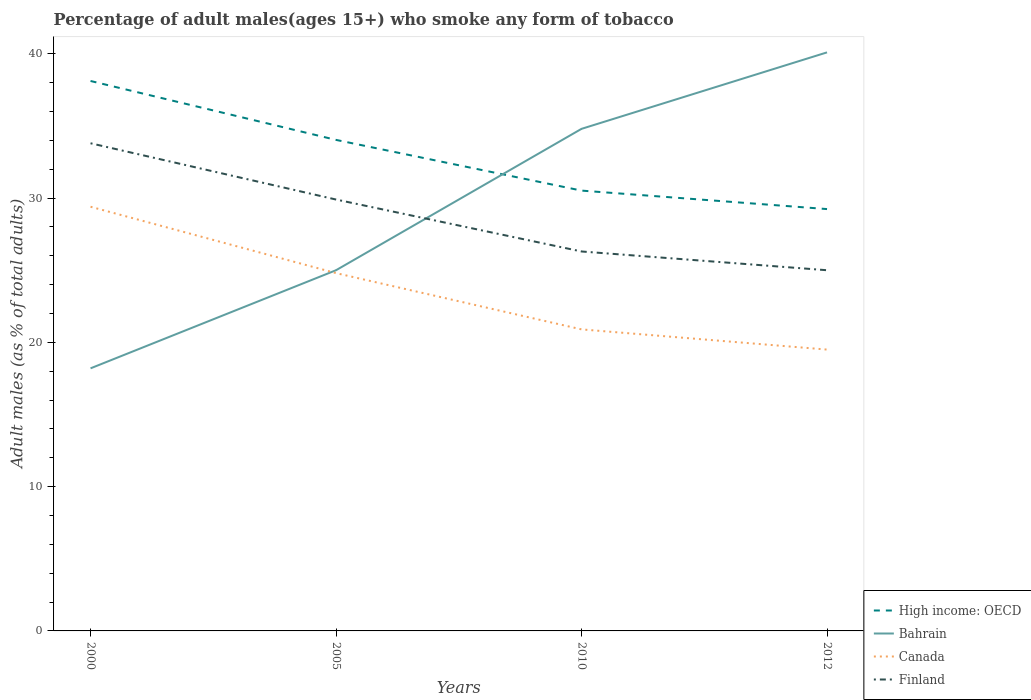How many different coloured lines are there?
Keep it short and to the point. 4. Is the number of lines equal to the number of legend labels?
Offer a terse response. Yes. What is the total percentage of adult males who smoke in Bahrain in the graph?
Your answer should be very brief. -9.8. What is the difference between the highest and the second highest percentage of adult males who smoke in Bahrain?
Make the answer very short. 21.9. How many lines are there?
Ensure brevity in your answer.  4. What is the difference between two consecutive major ticks on the Y-axis?
Offer a very short reply. 10. Does the graph contain any zero values?
Keep it short and to the point. No. Does the graph contain grids?
Offer a terse response. No. How are the legend labels stacked?
Give a very brief answer. Vertical. What is the title of the graph?
Your response must be concise. Percentage of adult males(ages 15+) who smoke any form of tobacco. What is the label or title of the X-axis?
Ensure brevity in your answer.  Years. What is the label or title of the Y-axis?
Offer a very short reply. Adult males (as % of total adults). What is the Adult males (as % of total adults) of High income: OECD in 2000?
Make the answer very short. 38.12. What is the Adult males (as % of total adults) in Bahrain in 2000?
Your answer should be compact. 18.2. What is the Adult males (as % of total adults) in Canada in 2000?
Keep it short and to the point. 29.4. What is the Adult males (as % of total adults) of Finland in 2000?
Offer a terse response. 33.8. What is the Adult males (as % of total adults) of High income: OECD in 2005?
Provide a succinct answer. 34.03. What is the Adult males (as % of total adults) of Bahrain in 2005?
Your answer should be very brief. 25. What is the Adult males (as % of total adults) of Canada in 2005?
Ensure brevity in your answer.  24.8. What is the Adult males (as % of total adults) of Finland in 2005?
Your response must be concise. 29.9. What is the Adult males (as % of total adults) in High income: OECD in 2010?
Give a very brief answer. 30.52. What is the Adult males (as % of total adults) of Bahrain in 2010?
Provide a succinct answer. 34.8. What is the Adult males (as % of total adults) of Canada in 2010?
Offer a very short reply. 20.9. What is the Adult males (as % of total adults) of Finland in 2010?
Ensure brevity in your answer.  26.3. What is the Adult males (as % of total adults) of High income: OECD in 2012?
Your response must be concise. 29.24. What is the Adult males (as % of total adults) in Bahrain in 2012?
Your answer should be very brief. 40.1. What is the Adult males (as % of total adults) in Canada in 2012?
Your answer should be compact. 19.5. What is the Adult males (as % of total adults) in Finland in 2012?
Your answer should be compact. 25. Across all years, what is the maximum Adult males (as % of total adults) of High income: OECD?
Offer a very short reply. 38.12. Across all years, what is the maximum Adult males (as % of total adults) in Bahrain?
Your answer should be very brief. 40.1. Across all years, what is the maximum Adult males (as % of total adults) in Canada?
Provide a short and direct response. 29.4. Across all years, what is the maximum Adult males (as % of total adults) of Finland?
Provide a short and direct response. 33.8. Across all years, what is the minimum Adult males (as % of total adults) of High income: OECD?
Your answer should be very brief. 29.24. Across all years, what is the minimum Adult males (as % of total adults) in Bahrain?
Your answer should be very brief. 18.2. Across all years, what is the minimum Adult males (as % of total adults) of Canada?
Give a very brief answer. 19.5. What is the total Adult males (as % of total adults) in High income: OECD in the graph?
Ensure brevity in your answer.  131.91. What is the total Adult males (as % of total adults) of Bahrain in the graph?
Provide a succinct answer. 118.1. What is the total Adult males (as % of total adults) of Canada in the graph?
Give a very brief answer. 94.6. What is the total Adult males (as % of total adults) in Finland in the graph?
Your answer should be compact. 115. What is the difference between the Adult males (as % of total adults) in High income: OECD in 2000 and that in 2005?
Give a very brief answer. 4.08. What is the difference between the Adult males (as % of total adults) of Bahrain in 2000 and that in 2005?
Make the answer very short. -6.8. What is the difference between the Adult males (as % of total adults) of High income: OECD in 2000 and that in 2010?
Offer a very short reply. 7.6. What is the difference between the Adult males (as % of total adults) in Bahrain in 2000 and that in 2010?
Offer a very short reply. -16.6. What is the difference between the Adult males (as % of total adults) in High income: OECD in 2000 and that in 2012?
Ensure brevity in your answer.  8.88. What is the difference between the Adult males (as % of total adults) in Bahrain in 2000 and that in 2012?
Give a very brief answer. -21.9. What is the difference between the Adult males (as % of total adults) of High income: OECD in 2005 and that in 2010?
Offer a very short reply. 3.51. What is the difference between the Adult males (as % of total adults) of Bahrain in 2005 and that in 2010?
Provide a short and direct response. -9.8. What is the difference between the Adult males (as % of total adults) of Canada in 2005 and that in 2010?
Your answer should be very brief. 3.9. What is the difference between the Adult males (as % of total adults) in High income: OECD in 2005 and that in 2012?
Ensure brevity in your answer.  4.79. What is the difference between the Adult males (as % of total adults) in Bahrain in 2005 and that in 2012?
Offer a very short reply. -15.1. What is the difference between the Adult males (as % of total adults) of High income: OECD in 2010 and that in 2012?
Ensure brevity in your answer.  1.28. What is the difference between the Adult males (as % of total adults) in Finland in 2010 and that in 2012?
Keep it short and to the point. 1.3. What is the difference between the Adult males (as % of total adults) of High income: OECD in 2000 and the Adult males (as % of total adults) of Bahrain in 2005?
Make the answer very short. 13.12. What is the difference between the Adult males (as % of total adults) of High income: OECD in 2000 and the Adult males (as % of total adults) of Canada in 2005?
Ensure brevity in your answer.  13.32. What is the difference between the Adult males (as % of total adults) in High income: OECD in 2000 and the Adult males (as % of total adults) in Finland in 2005?
Offer a very short reply. 8.22. What is the difference between the Adult males (as % of total adults) of Bahrain in 2000 and the Adult males (as % of total adults) of Canada in 2005?
Offer a terse response. -6.6. What is the difference between the Adult males (as % of total adults) in Bahrain in 2000 and the Adult males (as % of total adults) in Finland in 2005?
Make the answer very short. -11.7. What is the difference between the Adult males (as % of total adults) in Canada in 2000 and the Adult males (as % of total adults) in Finland in 2005?
Keep it short and to the point. -0.5. What is the difference between the Adult males (as % of total adults) in High income: OECD in 2000 and the Adult males (as % of total adults) in Bahrain in 2010?
Provide a short and direct response. 3.32. What is the difference between the Adult males (as % of total adults) in High income: OECD in 2000 and the Adult males (as % of total adults) in Canada in 2010?
Give a very brief answer. 17.22. What is the difference between the Adult males (as % of total adults) of High income: OECD in 2000 and the Adult males (as % of total adults) of Finland in 2010?
Offer a terse response. 11.82. What is the difference between the Adult males (as % of total adults) of Bahrain in 2000 and the Adult males (as % of total adults) of Canada in 2010?
Your response must be concise. -2.7. What is the difference between the Adult males (as % of total adults) in Bahrain in 2000 and the Adult males (as % of total adults) in Finland in 2010?
Keep it short and to the point. -8.1. What is the difference between the Adult males (as % of total adults) in Canada in 2000 and the Adult males (as % of total adults) in Finland in 2010?
Your answer should be compact. 3.1. What is the difference between the Adult males (as % of total adults) of High income: OECD in 2000 and the Adult males (as % of total adults) of Bahrain in 2012?
Provide a short and direct response. -1.98. What is the difference between the Adult males (as % of total adults) in High income: OECD in 2000 and the Adult males (as % of total adults) in Canada in 2012?
Keep it short and to the point. 18.62. What is the difference between the Adult males (as % of total adults) in High income: OECD in 2000 and the Adult males (as % of total adults) in Finland in 2012?
Your answer should be compact. 13.12. What is the difference between the Adult males (as % of total adults) of Bahrain in 2000 and the Adult males (as % of total adults) of Canada in 2012?
Provide a succinct answer. -1.3. What is the difference between the Adult males (as % of total adults) in High income: OECD in 2005 and the Adult males (as % of total adults) in Bahrain in 2010?
Your answer should be compact. -0.77. What is the difference between the Adult males (as % of total adults) of High income: OECD in 2005 and the Adult males (as % of total adults) of Canada in 2010?
Make the answer very short. 13.13. What is the difference between the Adult males (as % of total adults) of High income: OECD in 2005 and the Adult males (as % of total adults) of Finland in 2010?
Offer a very short reply. 7.73. What is the difference between the Adult males (as % of total adults) in Bahrain in 2005 and the Adult males (as % of total adults) in Canada in 2010?
Offer a terse response. 4.1. What is the difference between the Adult males (as % of total adults) of Canada in 2005 and the Adult males (as % of total adults) of Finland in 2010?
Your answer should be compact. -1.5. What is the difference between the Adult males (as % of total adults) of High income: OECD in 2005 and the Adult males (as % of total adults) of Bahrain in 2012?
Your answer should be very brief. -6.07. What is the difference between the Adult males (as % of total adults) in High income: OECD in 2005 and the Adult males (as % of total adults) in Canada in 2012?
Make the answer very short. 14.53. What is the difference between the Adult males (as % of total adults) in High income: OECD in 2005 and the Adult males (as % of total adults) in Finland in 2012?
Your answer should be compact. 9.03. What is the difference between the Adult males (as % of total adults) in Bahrain in 2005 and the Adult males (as % of total adults) in Canada in 2012?
Provide a succinct answer. 5.5. What is the difference between the Adult males (as % of total adults) of Canada in 2005 and the Adult males (as % of total adults) of Finland in 2012?
Provide a short and direct response. -0.2. What is the difference between the Adult males (as % of total adults) in High income: OECD in 2010 and the Adult males (as % of total adults) in Bahrain in 2012?
Offer a very short reply. -9.58. What is the difference between the Adult males (as % of total adults) of High income: OECD in 2010 and the Adult males (as % of total adults) of Canada in 2012?
Your response must be concise. 11.02. What is the difference between the Adult males (as % of total adults) of High income: OECD in 2010 and the Adult males (as % of total adults) of Finland in 2012?
Provide a succinct answer. 5.52. What is the difference between the Adult males (as % of total adults) in Bahrain in 2010 and the Adult males (as % of total adults) in Canada in 2012?
Provide a succinct answer. 15.3. What is the average Adult males (as % of total adults) in High income: OECD per year?
Make the answer very short. 32.98. What is the average Adult males (as % of total adults) of Bahrain per year?
Offer a very short reply. 29.52. What is the average Adult males (as % of total adults) of Canada per year?
Your response must be concise. 23.65. What is the average Adult males (as % of total adults) in Finland per year?
Provide a short and direct response. 28.75. In the year 2000, what is the difference between the Adult males (as % of total adults) in High income: OECD and Adult males (as % of total adults) in Bahrain?
Give a very brief answer. 19.92. In the year 2000, what is the difference between the Adult males (as % of total adults) in High income: OECD and Adult males (as % of total adults) in Canada?
Offer a terse response. 8.72. In the year 2000, what is the difference between the Adult males (as % of total adults) of High income: OECD and Adult males (as % of total adults) of Finland?
Ensure brevity in your answer.  4.32. In the year 2000, what is the difference between the Adult males (as % of total adults) in Bahrain and Adult males (as % of total adults) in Canada?
Give a very brief answer. -11.2. In the year 2000, what is the difference between the Adult males (as % of total adults) of Bahrain and Adult males (as % of total adults) of Finland?
Provide a short and direct response. -15.6. In the year 2005, what is the difference between the Adult males (as % of total adults) of High income: OECD and Adult males (as % of total adults) of Bahrain?
Keep it short and to the point. 9.03. In the year 2005, what is the difference between the Adult males (as % of total adults) in High income: OECD and Adult males (as % of total adults) in Canada?
Keep it short and to the point. 9.23. In the year 2005, what is the difference between the Adult males (as % of total adults) in High income: OECD and Adult males (as % of total adults) in Finland?
Give a very brief answer. 4.13. In the year 2005, what is the difference between the Adult males (as % of total adults) in Bahrain and Adult males (as % of total adults) in Finland?
Your answer should be compact. -4.9. In the year 2010, what is the difference between the Adult males (as % of total adults) in High income: OECD and Adult males (as % of total adults) in Bahrain?
Provide a short and direct response. -4.28. In the year 2010, what is the difference between the Adult males (as % of total adults) of High income: OECD and Adult males (as % of total adults) of Canada?
Provide a short and direct response. 9.62. In the year 2010, what is the difference between the Adult males (as % of total adults) of High income: OECD and Adult males (as % of total adults) of Finland?
Offer a terse response. 4.22. In the year 2010, what is the difference between the Adult males (as % of total adults) in Bahrain and Adult males (as % of total adults) in Finland?
Your response must be concise. 8.5. In the year 2012, what is the difference between the Adult males (as % of total adults) of High income: OECD and Adult males (as % of total adults) of Bahrain?
Your answer should be compact. -10.86. In the year 2012, what is the difference between the Adult males (as % of total adults) in High income: OECD and Adult males (as % of total adults) in Canada?
Offer a very short reply. 9.74. In the year 2012, what is the difference between the Adult males (as % of total adults) in High income: OECD and Adult males (as % of total adults) in Finland?
Provide a succinct answer. 4.24. In the year 2012, what is the difference between the Adult males (as % of total adults) of Bahrain and Adult males (as % of total adults) of Canada?
Your response must be concise. 20.6. What is the ratio of the Adult males (as % of total adults) in High income: OECD in 2000 to that in 2005?
Offer a terse response. 1.12. What is the ratio of the Adult males (as % of total adults) in Bahrain in 2000 to that in 2005?
Make the answer very short. 0.73. What is the ratio of the Adult males (as % of total adults) in Canada in 2000 to that in 2005?
Make the answer very short. 1.19. What is the ratio of the Adult males (as % of total adults) in Finland in 2000 to that in 2005?
Offer a terse response. 1.13. What is the ratio of the Adult males (as % of total adults) of High income: OECD in 2000 to that in 2010?
Keep it short and to the point. 1.25. What is the ratio of the Adult males (as % of total adults) in Bahrain in 2000 to that in 2010?
Your response must be concise. 0.52. What is the ratio of the Adult males (as % of total adults) in Canada in 2000 to that in 2010?
Offer a very short reply. 1.41. What is the ratio of the Adult males (as % of total adults) in Finland in 2000 to that in 2010?
Ensure brevity in your answer.  1.29. What is the ratio of the Adult males (as % of total adults) of High income: OECD in 2000 to that in 2012?
Provide a succinct answer. 1.3. What is the ratio of the Adult males (as % of total adults) in Bahrain in 2000 to that in 2012?
Your response must be concise. 0.45. What is the ratio of the Adult males (as % of total adults) in Canada in 2000 to that in 2012?
Your response must be concise. 1.51. What is the ratio of the Adult males (as % of total adults) of Finland in 2000 to that in 2012?
Offer a very short reply. 1.35. What is the ratio of the Adult males (as % of total adults) of High income: OECD in 2005 to that in 2010?
Ensure brevity in your answer.  1.12. What is the ratio of the Adult males (as % of total adults) of Bahrain in 2005 to that in 2010?
Offer a very short reply. 0.72. What is the ratio of the Adult males (as % of total adults) in Canada in 2005 to that in 2010?
Your answer should be very brief. 1.19. What is the ratio of the Adult males (as % of total adults) in Finland in 2005 to that in 2010?
Give a very brief answer. 1.14. What is the ratio of the Adult males (as % of total adults) of High income: OECD in 2005 to that in 2012?
Make the answer very short. 1.16. What is the ratio of the Adult males (as % of total adults) of Bahrain in 2005 to that in 2012?
Keep it short and to the point. 0.62. What is the ratio of the Adult males (as % of total adults) in Canada in 2005 to that in 2012?
Offer a terse response. 1.27. What is the ratio of the Adult males (as % of total adults) of Finland in 2005 to that in 2012?
Your answer should be very brief. 1.2. What is the ratio of the Adult males (as % of total adults) in High income: OECD in 2010 to that in 2012?
Ensure brevity in your answer.  1.04. What is the ratio of the Adult males (as % of total adults) of Bahrain in 2010 to that in 2012?
Keep it short and to the point. 0.87. What is the ratio of the Adult males (as % of total adults) of Canada in 2010 to that in 2012?
Your answer should be very brief. 1.07. What is the ratio of the Adult males (as % of total adults) of Finland in 2010 to that in 2012?
Provide a succinct answer. 1.05. What is the difference between the highest and the second highest Adult males (as % of total adults) of High income: OECD?
Provide a succinct answer. 4.08. What is the difference between the highest and the lowest Adult males (as % of total adults) of High income: OECD?
Your answer should be very brief. 8.88. What is the difference between the highest and the lowest Adult males (as % of total adults) of Bahrain?
Offer a terse response. 21.9. What is the difference between the highest and the lowest Adult males (as % of total adults) in Canada?
Your answer should be compact. 9.9. 